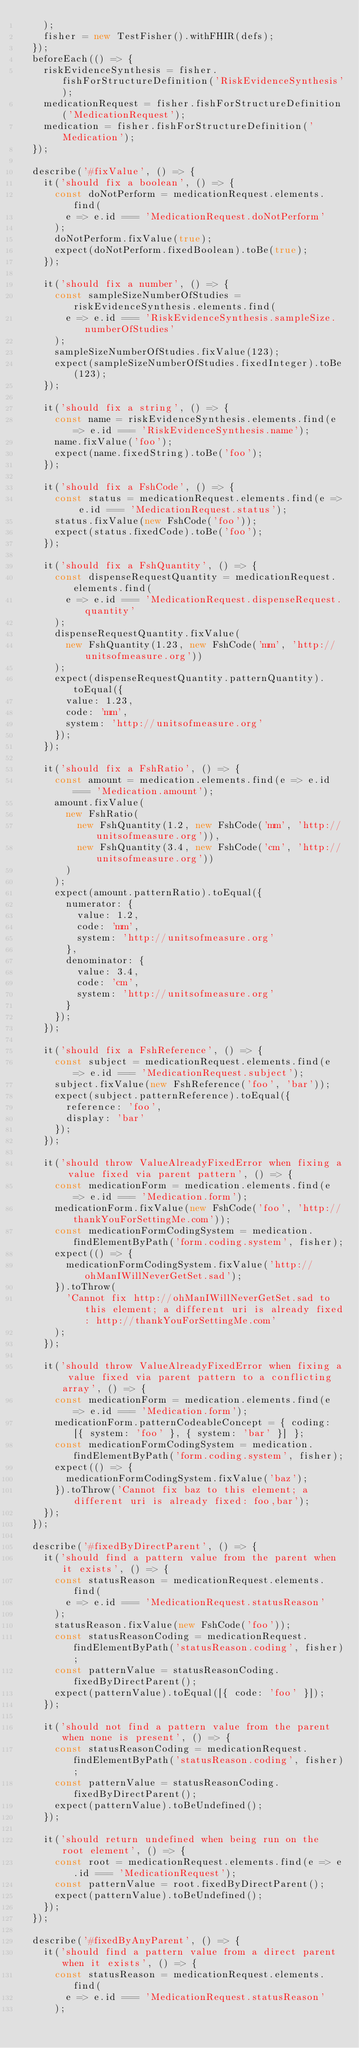Convert code to text. <code><loc_0><loc_0><loc_500><loc_500><_TypeScript_>    );
    fisher = new TestFisher().withFHIR(defs);
  });
  beforeEach(() => {
    riskEvidenceSynthesis = fisher.fishForStructureDefinition('RiskEvidenceSynthesis');
    medicationRequest = fisher.fishForStructureDefinition('MedicationRequest');
    medication = fisher.fishForStructureDefinition('Medication');
  });

  describe('#fixValue', () => {
    it('should fix a boolean', () => {
      const doNotPerform = medicationRequest.elements.find(
        e => e.id === 'MedicationRequest.doNotPerform'
      );
      doNotPerform.fixValue(true);
      expect(doNotPerform.fixedBoolean).toBe(true);
    });

    it('should fix a number', () => {
      const sampleSizeNumberOfStudies = riskEvidenceSynthesis.elements.find(
        e => e.id === 'RiskEvidenceSynthesis.sampleSize.numberOfStudies'
      );
      sampleSizeNumberOfStudies.fixValue(123);
      expect(sampleSizeNumberOfStudies.fixedInteger).toBe(123);
    });

    it('should fix a string', () => {
      const name = riskEvidenceSynthesis.elements.find(e => e.id === 'RiskEvidenceSynthesis.name');
      name.fixValue('foo');
      expect(name.fixedString).toBe('foo');
    });

    it('should fix a FshCode', () => {
      const status = medicationRequest.elements.find(e => e.id === 'MedicationRequest.status');
      status.fixValue(new FshCode('foo'));
      expect(status.fixedCode).toBe('foo');
    });

    it('should fix a FshQuantity', () => {
      const dispenseRequestQuantity = medicationRequest.elements.find(
        e => e.id === 'MedicationRequest.dispenseRequest.quantity'
      );
      dispenseRequestQuantity.fixValue(
        new FshQuantity(1.23, new FshCode('mm', 'http://unitsofmeasure.org'))
      );
      expect(dispenseRequestQuantity.patternQuantity).toEqual({
        value: 1.23,
        code: 'mm',
        system: 'http://unitsofmeasure.org'
      });
    });

    it('should fix a FshRatio', () => {
      const amount = medication.elements.find(e => e.id === 'Medication.amount');
      amount.fixValue(
        new FshRatio(
          new FshQuantity(1.2, new FshCode('mm', 'http://unitsofmeasure.org')),
          new FshQuantity(3.4, new FshCode('cm', 'http://unitsofmeasure.org'))
        )
      );
      expect(amount.patternRatio).toEqual({
        numerator: {
          value: 1.2,
          code: 'mm',
          system: 'http://unitsofmeasure.org'
        },
        denominator: {
          value: 3.4,
          code: 'cm',
          system: 'http://unitsofmeasure.org'
        }
      });
    });

    it('should fix a FshReference', () => {
      const subject = medicationRequest.elements.find(e => e.id === 'MedicationRequest.subject');
      subject.fixValue(new FshReference('foo', 'bar'));
      expect(subject.patternReference).toEqual({
        reference: 'foo',
        display: 'bar'
      });
    });

    it('should throw ValueAlreadyFixedError when fixing a value fixed via parent pattern', () => {
      const medicationForm = medication.elements.find(e => e.id === 'Medication.form');
      medicationForm.fixValue(new FshCode('foo', 'http://thankYouForSettingMe.com'));
      const medicationFormCodingSystem = medication.findElementByPath('form.coding.system', fisher);
      expect(() => {
        medicationFormCodingSystem.fixValue('http://ohManIWillNeverGetSet.sad');
      }).toThrow(
        'Cannot fix http://ohManIWillNeverGetSet.sad to this element; a different uri is already fixed: http://thankYouForSettingMe.com'
      );
    });

    it('should throw ValueAlreadyFixedError when fixing a value fixed via parent pattern to a conflicting array', () => {
      const medicationForm = medication.elements.find(e => e.id === 'Medication.form');
      medicationForm.patternCodeableConcept = { coding: [{ system: 'foo' }, { system: 'bar' }] };
      const medicationFormCodingSystem = medication.findElementByPath('form.coding.system', fisher);
      expect(() => {
        medicationFormCodingSystem.fixValue('baz');
      }).toThrow('Cannot fix baz to this element; a different uri is already fixed: foo,bar');
    });
  });

  describe('#fixedByDirectParent', () => {
    it('should find a pattern value from the parent when it exists', () => {
      const statusReason = medicationRequest.elements.find(
        e => e.id === 'MedicationRequest.statusReason'
      );
      statusReason.fixValue(new FshCode('foo'));
      const statusReasonCoding = medicationRequest.findElementByPath('statusReason.coding', fisher);
      const patternValue = statusReasonCoding.fixedByDirectParent();
      expect(patternValue).toEqual([{ code: 'foo' }]);
    });

    it('should not find a pattern value from the parent when none is present', () => {
      const statusReasonCoding = medicationRequest.findElementByPath('statusReason.coding', fisher);
      const patternValue = statusReasonCoding.fixedByDirectParent();
      expect(patternValue).toBeUndefined();
    });

    it('should return undefined when being run on the root element', () => {
      const root = medicationRequest.elements.find(e => e.id === 'MedicationRequest');
      const patternValue = root.fixedByDirectParent();
      expect(patternValue).toBeUndefined();
    });
  });

  describe('#fixedByAnyParent', () => {
    it('should find a pattern value from a direct parent when it exists', () => {
      const statusReason = medicationRequest.elements.find(
        e => e.id === 'MedicationRequest.statusReason'
      );</code> 